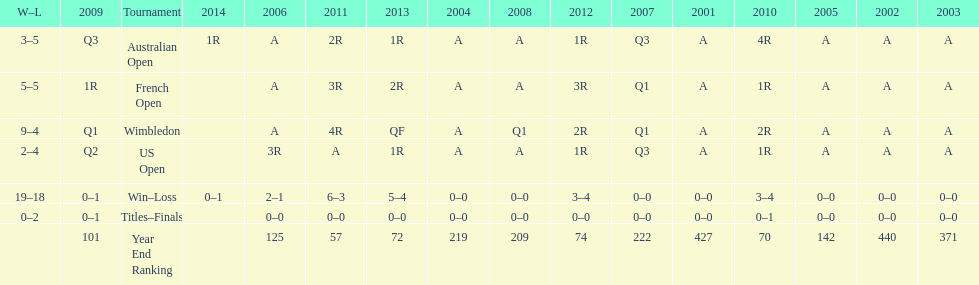Which years was a ranking below 200 achieved? 2005, 2006, 2009, 2010, 2011, 2012, 2013. 